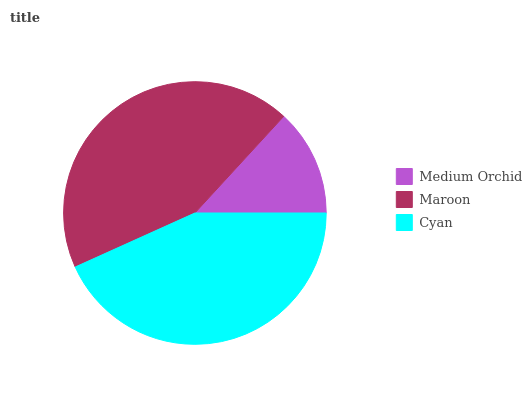Is Medium Orchid the minimum?
Answer yes or no. Yes. Is Maroon the maximum?
Answer yes or no. Yes. Is Cyan the minimum?
Answer yes or no. No. Is Cyan the maximum?
Answer yes or no. No. Is Maroon greater than Cyan?
Answer yes or no. Yes. Is Cyan less than Maroon?
Answer yes or no. Yes. Is Cyan greater than Maroon?
Answer yes or no. No. Is Maroon less than Cyan?
Answer yes or no. No. Is Cyan the high median?
Answer yes or no. Yes. Is Cyan the low median?
Answer yes or no. Yes. Is Maroon the high median?
Answer yes or no. No. Is Maroon the low median?
Answer yes or no. No. 